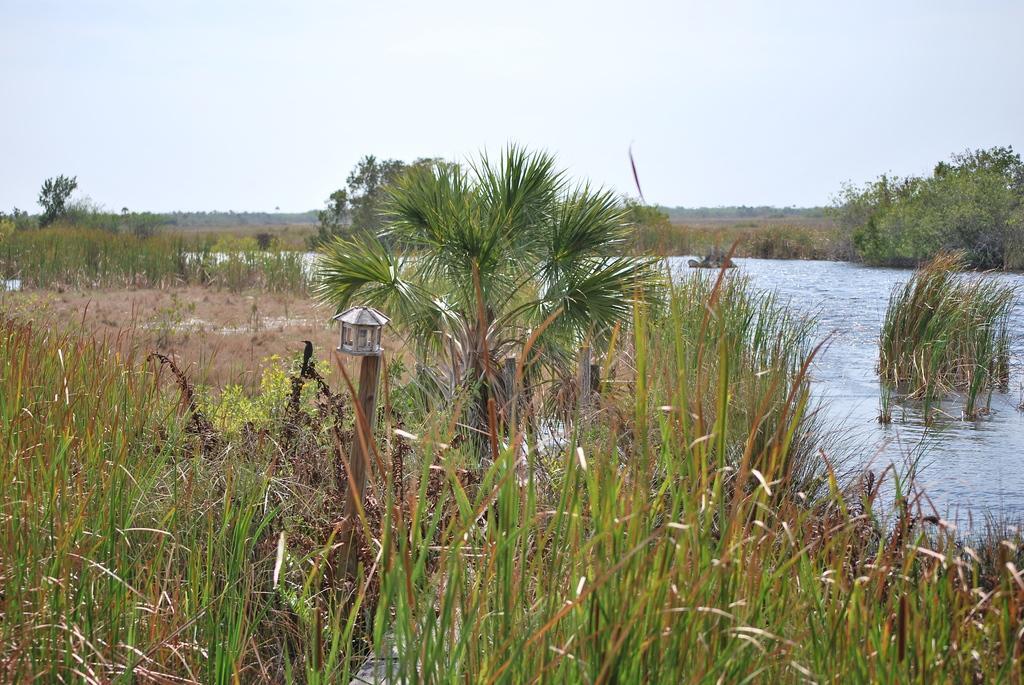How would you summarize this image in a sentence or two? In this image we can see many trees and plants. Also there is a pole with something on that. And there is water. In the background there is sky. 